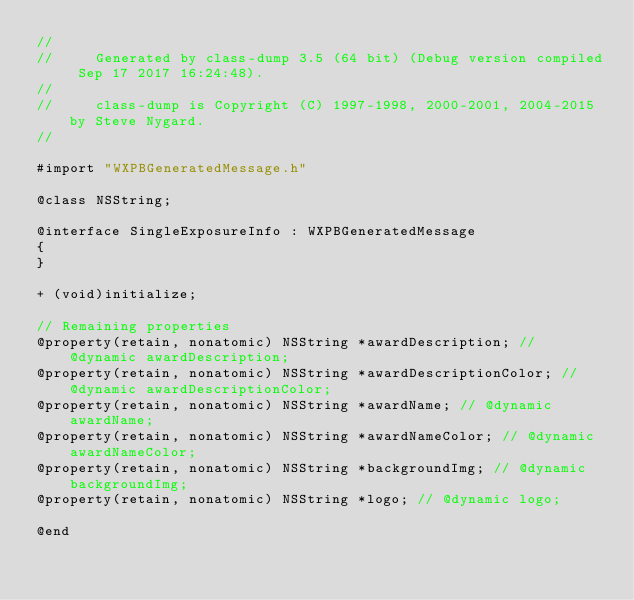Convert code to text. <code><loc_0><loc_0><loc_500><loc_500><_C_>//
//     Generated by class-dump 3.5 (64 bit) (Debug version compiled Sep 17 2017 16:24:48).
//
//     class-dump is Copyright (C) 1997-1998, 2000-2001, 2004-2015 by Steve Nygard.
//

#import "WXPBGeneratedMessage.h"

@class NSString;

@interface SingleExposureInfo : WXPBGeneratedMessage
{
}

+ (void)initialize;

// Remaining properties
@property(retain, nonatomic) NSString *awardDescription; // @dynamic awardDescription;
@property(retain, nonatomic) NSString *awardDescriptionColor; // @dynamic awardDescriptionColor;
@property(retain, nonatomic) NSString *awardName; // @dynamic awardName;
@property(retain, nonatomic) NSString *awardNameColor; // @dynamic awardNameColor;
@property(retain, nonatomic) NSString *backgroundImg; // @dynamic backgroundImg;
@property(retain, nonatomic) NSString *logo; // @dynamic logo;

@end

</code> 